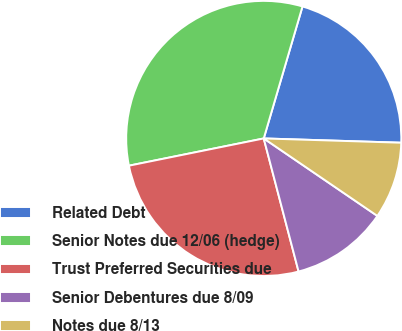Convert chart. <chart><loc_0><loc_0><loc_500><loc_500><pie_chart><fcel>Related Debt<fcel>Senior Notes due 12/06 (hedge)<fcel>Trust Preferred Securities due<fcel>Senior Debentures due 8/09<fcel>Notes due 8/13<nl><fcel>20.95%<fcel>32.72%<fcel>25.9%<fcel>11.4%<fcel>9.03%<nl></chart> 